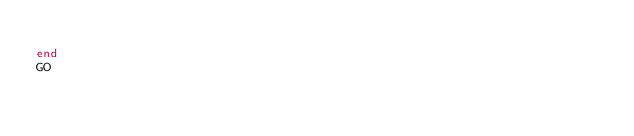Convert code to text. <code><loc_0><loc_0><loc_500><loc_500><_SQL_>	
end
GO
</code> 